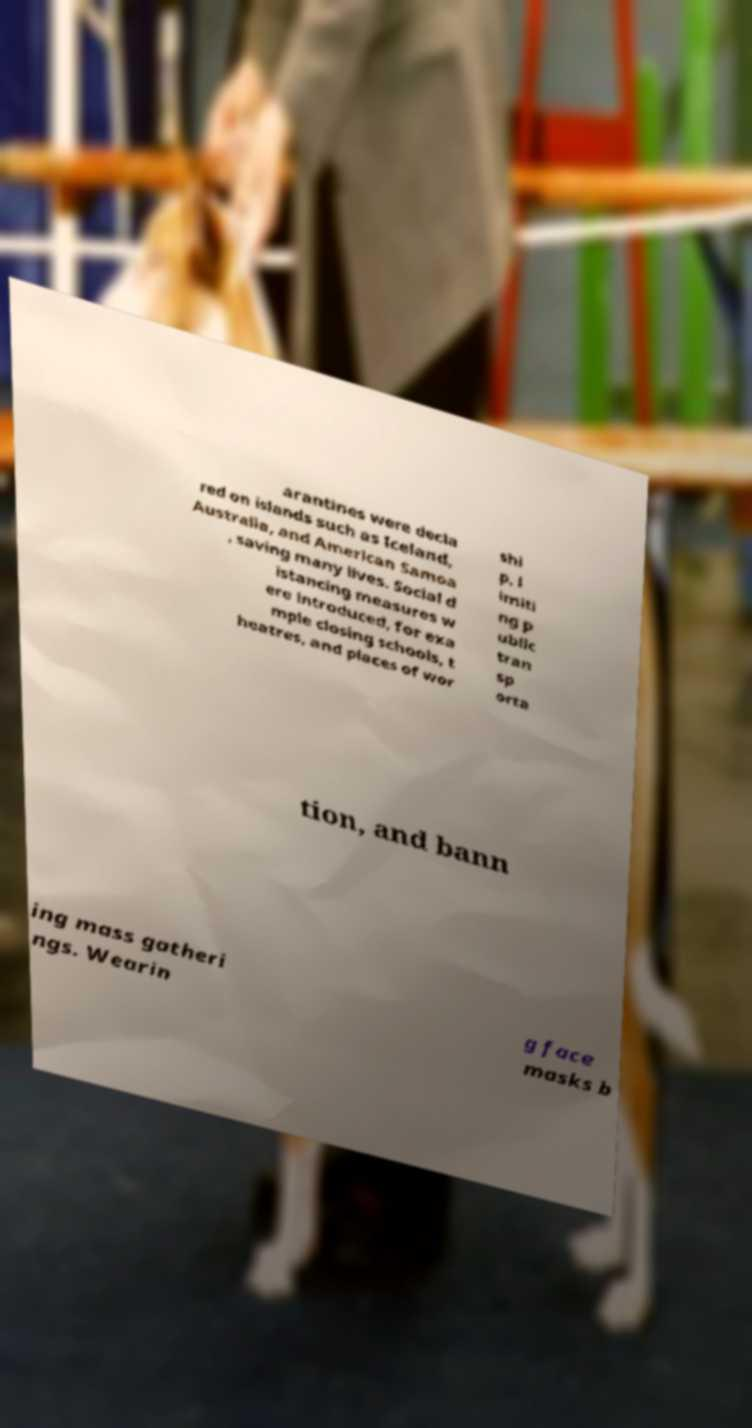What messages or text are displayed in this image? I need them in a readable, typed format. arantines were decla red on islands such as Iceland, Australia, and American Samoa , saving many lives. Social d istancing measures w ere introduced, for exa mple closing schools, t heatres, and places of wor shi p, l imiti ng p ublic tran sp orta tion, and bann ing mass gatheri ngs. Wearin g face masks b 